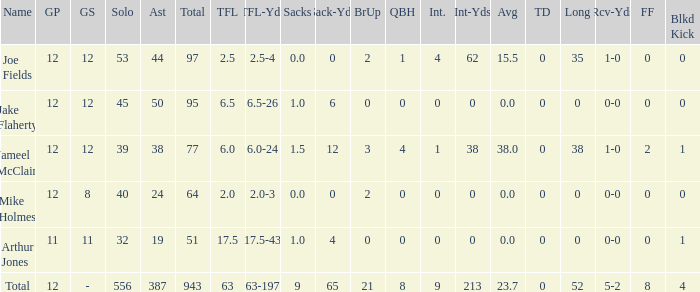How many players named jake flaherty? 1.0. 